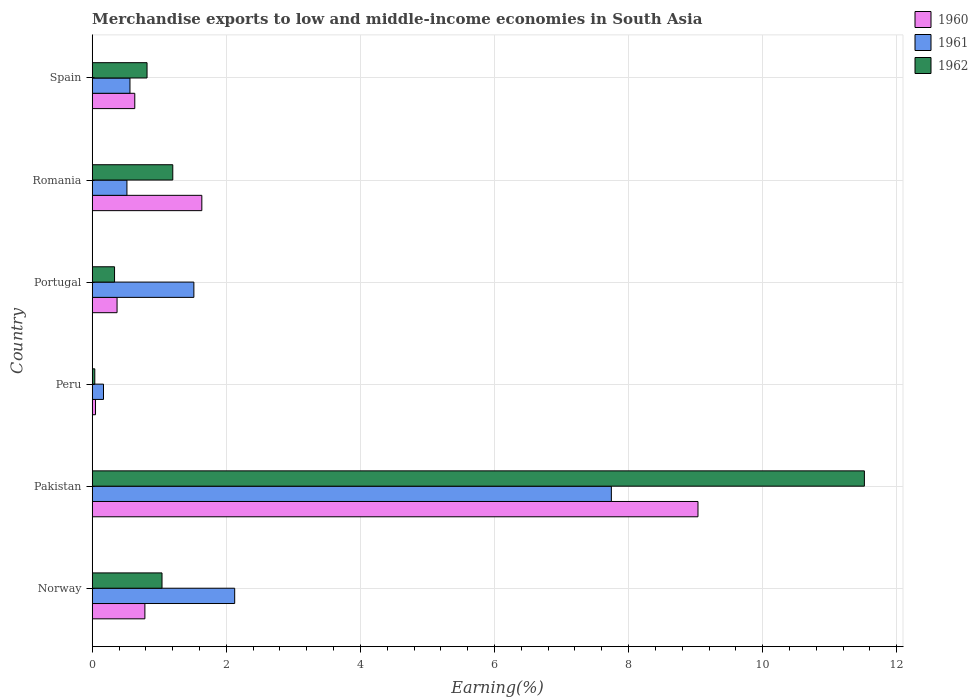How many different coloured bars are there?
Ensure brevity in your answer.  3. How many groups of bars are there?
Provide a short and direct response. 6. Are the number of bars per tick equal to the number of legend labels?
Your response must be concise. Yes. Are the number of bars on each tick of the Y-axis equal?
Keep it short and to the point. Yes. How many bars are there on the 3rd tick from the top?
Make the answer very short. 3. What is the label of the 2nd group of bars from the top?
Keep it short and to the point. Romania. In how many cases, is the number of bars for a given country not equal to the number of legend labels?
Offer a very short reply. 0. What is the percentage of amount earned from merchandise exports in 1960 in Portugal?
Your response must be concise. 0.37. Across all countries, what is the maximum percentage of amount earned from merchandise exports in 1962?
Provide a short and direct response. 11.52. Across all countries, what is the minimum percentage of amount earned from merchandise exports in 1961?
Provide a succinct answer. 0.17. In which country was the percentage of amount earned from merchandise exports in 1962 maximum?
Ensure brevity in your answer.  Pakistan. What is the total percentage of amount earned from merchandise exports in 1961 in the graph?
Your answer should be very brief. 12.63. What is the difference between the percentage of amount earned from merchandise exports in 1960 in Pakistan and that in Spain?
Make the answer very short. 8.4. What is the difference between the percentage of amount earned from merchandise exports in 1961 in Peru and the percentage of amount earned from merchandise exports in 1962 in Norway?
Make the answer very short. -0.87. What is the average percentage of amount earned from merchandise exports in 1960 per country?
Give a very brief answer. 2.08. What is the difference between the percentage of amount earned from merchandise exports in 1960 and percentage of amount earned from merchandise exports in 1961 in Portugal?
Provide a short and direct response. -1.15. What is the ratio of the percentage of amount earned from merchandise exports in 1962 in Romania to that in Spain?
Your response must be concise. 1.47. Is the percentage of amount earned from merchandise exports in 1961 in Norway less than that in Pakistan?
Keep it short and to the point. Yes. Is the difference between the percentage of amount earned from merchandise exports in 1960 in Portugal and Spain greater than the difference between the percentage of amount earned from merchandise exports in 1961 in Portugal and Spain?
Keep it short and to the point. No. What is the difference between the highest and the second highest percentage of amount earned from merchandise exports in 1961?
Your response must be concise. 5.62. What is the difference between the highest and the lowest percentage of amount earned from merchandise exports in 1962?
Your answer should be very brief. 11.48. Is the sum of the percentage of amount earned from merchandise exports in 1962 in Pakistan and Peru greater than the maximum percentage of amount earned from merchandise exports in 1961 across all countries?
Make the answer very short. Yes. What does the 2nd bar from the bottom in Peru represents?
Make the answer very short. 1961. What is the difference between two consecutive major ticks on the X-axis?
Your answer should be very brief. 2. Does the graph contain grids?
Your answer should be very brief. Yes. Where does the legend appear in the graph?
Provide a short and direct response. Top right. How many legend labels are there?
Give a very brief answer. 3. What is the title of the graph?
Make the answer very short. Merchandise exports to low and middle-income economies in South Asia. What is the label or title of the X-axis?
Provide a short and direct response. Earning(%). What is the label or title of the Y-axis?
Your answer should be compact. Country. What is the Earning(%) in 1960 in Norway?
Make the answer very short. 0.79. What is the Earning(%) of 1961 in Norway?
Your answer should be very brief. 2.12. What is the Earning(%) in 1962 in Norway?
Your response must be concise. 1.04. What is the Earning(%) of 1960 in Pakistan?
Your response must be concise. 9.04. What is the Earning(%) in 1961 in Pakistan?
Your response must be concise. 7.74. What is the Earning(%) of 1962 in Pakistan?
Your response must be concise. 11.52. What is the Earning(%) in 1960 in Peru?
Make the answer very short. 0.05. What is the Earning(%) in 1961 in Peru?
Your response must be concise. 0.17. What is the Earning(%) in 1962 in Peru?
Keep it short and to the point. 0.04. What is the Earning(%) in 1960 in Portugal?
Make the answer very short. 0.37. What is the Earning(%) in 1961 in Portugal?
Offer a terse response. 1.52. What is the Earning(%) of 1962 in Portugal?
Ensure brevity in your answer.  0.33. What is the Earning(%) of 1960 in Romania?
Make the answer very short. 1.63. What is the Earning(%) in 1961 in Romania?
Make the answer very short. 0.52. What is the Earning(%) in 1962 in Romania?
Give a very brief answer. 1.2. What is the Earning(%) in 1960 in Spain?
Make the answer very short. 0.63. What is the Earning(%) of 1961 in Spain?
Your response must be concise. 0.56. What is the Earning(%) of 1962 in Spain?
Your response must be concise. 0.82. Across all countries, what is the maximum Earning(%) in 1960?
Provide a succinct answer. 9.04. Across all countries, what is the maximum Earning(%) in 1961?
Offer a very short reply. 7.74. Across all countries, what is the maximum Earning(%) in 1962?
Make the answer very short. 11.52. Across all countries, what is the minimum Earning(%) of 1960?
Provide a short and direct response. 0.05. Across all countries, what is the minimum Earning(%) of 1961?
Offer a very short reply. 0.17. Across all countries, what is the minimum Earning(%) in 1962?
Provide a succinct answer. 0.04. What is the total Earning(%) of 1960 in the graph?
Your answer should be compact. 12.51. What is the total Earning(%) in 1961 in the graph?
Offer a terse response. 12.63. What is the total Earning(%) of 1962 in the graph?
Provide a short and direct response. 14.95. What is the difference between the Earning(%) of 1960 in Norway and that in Pakistan?
Make the answer very short. -8.25. What is the difference between the Earning(%) of 1961 in Norway and that in Pakistan?
Offer a very short reply. -5.62. What is the difference between the Earning(%) in 1962 in Norway and that in Pakistan?
Keep it short and to the point. -10.48. What is the difference between the Earning(%) of 1960 in Norway and that in Peru?
Offer a very short reply. 0.74. What is the difference between the Earning(%) in 1961 in Norway and that in Peru?
Provide a short and direct response. 1.96. What is the difference between the Earning(%) in 1962 in Norway and that in Peru?
Provide a succinct answer. 1. What is the difference between the Earning(%) of 1960 in Norway and that in Portugal?
Offer a terse response. 0.42. What is the difference between the Earning(%) in 1961 in Norway and that in Portugal?
Provide a short and direct response. 0.61. What is the difference between the Earning(%) in 1962 in Norway and that in Portugal?
Your answer should be compact. 0.71. What is the difference between the Earning(%) of 1960 in Norway and that in Romania?
Make the answer very short. -0.85. What is the difference between the Earning(%) of 1961 in Norway and that in Romania?
Offer a terse response. 1.61. What is the difference between the Earning(%) in 1962 in Norway and that in Romania?
Ensure brevity in your answer.  -0.16. What is the difference between the Earning(%) of 1960 in Norway and that in Spain?
Ensure brevity in your answer.  0.15. What is the difference between the Earning(%) of 1961 in Norway and that in Spain?
Provide a succinct answer. 1.56. What is the difference between the Earning(%) of 1962 in Norway and that in Spain?
Make the answer very short. 0.22. What is the difference between the Earning(%) of 1960 in Pakistan and that in Peru?
Your response must be concise. 8.99. What is the difference between the Earning(%) in 1961 in Pakistan and that in Peru?
Offer a terse response. 7.58. What is the difference between the Earning(%) of 1962 in Pakistan and that in Peru?
Ensure brevity in your answer.  11.48. What is the difference between the Earning(%) in 1960 in Pakistan and that in Portugal?
Offer a terse response. 8.67. What is the difference between the Earning(%) in 1961 in Pakistan and that in Portugal?
Provide a succinct answer. 6.23. What is the difference between the Earning(%) in 1962 in Pakistan and that in Portugal?
Make the answer very short. 11.18. What is the difference between the Earning(%) in 1960 in Pakistan and that in Romania?
Give a very brief answer. 7.4. What is the difference between the Earning(%) of 1961 in Pakistan and that in Romania?
Your answer should be very brief. 7.23. What is the difference between the Earning(%) of 1962 in Pakistan and that in Romania?
Provide a short and direct response. 10.32. What is the difference between the Earning(%) in 1960 in Pakistan and that in Spain?
Provide a succinct answer. 8.4. What is the difference between the Earning(%) of 1961 in Pakistan and that in Spain?
Your response must be concise. 7.18. What is the difference between the Earning(%) of 1962 in Pakistan and that in Spain?
Make the answer very short. 10.7. What is the difference between the Earning(%) of 1960 in Peru and that in Portugal?
Your answer should be compact. -0.32. What is the difference between the Earning(%) in 1961 in Peru and that in Portugal?
Keep it short and to the point. -1.35. What is the difference between the Earning(%) of 1962 in Peru and that in Portugal?
Your response must be concise. -0.29. What is the difference between the Earning(%) in 1960 in Peru and that in Romania?
Your answer should be compact. -1.59. What is the difference between the Earning(%) of 1961 in Peru and that in Romania?
Make the answer very short. -0.35. What is the difference between the Earning(%) of 1962 in Peru and that in Romania?
Offer a very short reply. -1.16. What is the difference between the Earning(%) in 1960 in Peru and that in Spain?
Provide a short and direct response. -0.59. What is the difference between the Earning(%) in 1961 in Peru and that in Spain?
Your answer should be compact. -0.39. What is the difference between the Earning(%) of 1962 in Peru and that in Spain?
Make the answer very short. -0.78. What is the difference between the Earning(%) of 1960 in Portugal and that in Romania?
Ensure brevity in your answer.  -1.26. What is the difference between the Earning(%) in 1961 in Portugal and that in Romania?
Make the answer very short. 1. What is the difference between the Earning(%) in 1962 in Portugal and that in Romania?
Keep it short and to the point. -0.87. What is the difference between the Earning(%) in 1960 in Portugal and that in Spain?
Provide a short and direct response. -0.26. What is the difference between the Earning(%) of 1961 in Portugal and that in Spain?
Give a very brief answer. 0.95. What is the difference between the Earning(%) in 1962 in Portugal and that in Spain?
Provide a short and direct response. -0.48. What is the difference between the Earning(%) in 1960 in Romania and that in Spain?
Your answer should be very brief. 1. What is the difference between the Earning(%) in 1961 in Romania and that in Spain?
Offer a terse response. -0.05. What is the difference between the Earning(%) of 1962 in Romania and that in Spain?
Your answer should be very brief. 0.38. What is the difference between the Earning(%) in 1960 in Norway and the Earning(%) in 1961 in Pakistan?
Keep it short and to the point. -6.96. What is the difference between the Earning(%) of 1960 in Norway and the Earning(%) of 1962 in Pakistan?
Provide a short and direct response. -10.73. What is the difference between the Earning(%) in 1961 in Norway and the Earning(%) in 1962 in Pakistan?
Keep it short and to the point. -9.39. What is the difference between the Earning(%) of 1960 in Norway and the Earning(%) of 1961 in Peru?
Make the answer very short. 0.62. What is the difference between the Earning(%) of 1960 in Norway and the Earning(%) of 1962 in Peru?
Offer a very short reply. 0.75. What is the difference between the Earning(%) of 1961 in Norway and the Earning(%) of 1962 in Peru?
Provide a succinct answer. 2.09. What is the difference between the Earning(%) of 1960 in Norway and the Earning(%) of 1961 in Portugal?
Give a very brief answer. -0.73. What is the difference between the Earning(%) in 1960 in Norway and the Earning(%) in 1962 in Portugal?
Offer a very short reply. 0.45. What is the difference between the Earning(%) in 1961 in Norway and the Earning(%) in 1962 in Portugal?
Your response must be concise. 1.79. What is the difference between the Earning(%) in 1960 in Norway and the Earning(%) in 1961 in Romania?
Your answer should be compact. 0.27. What is the difference between the Earning(%) in 1960 in Norway and the Earning(%) in 1962 in Romania?
Ensure brevity in your answer.  -0.42. What is the difference between the Earning(%) in 1961 in Norway and the Earning(%) in 1962 in Romania?
Your response must be concise. 0.92. What is the difference between the Earning(%) of 1960 in Norway and the Earning(%) of 1961 in Spain?
Make the answer very short. 0.22. What is the difference between the Earning(%) in 1960 in Norway and the Earning(%) in 1962 in Spain?
Keep it short and to the point. -0.03. What is the difference between the Earning(%) of 1961 in Norway and the Earning(%) of 1962 in Spain?
Offer a terse response. 1.31. What is the difference between the Earning(%) in 1960 in Pakistan and the Earning(%) in 1961 in Peru?
Make the answer very short. 8.87. What is the difference between the Earning(%) in 1960 in Pakistan and the Earning(%) in 1962 in Peru?
Make the answer very short. 9. What is the difference between the Earning(%) of 1961 in Pakistan and the Earning(%) of 1962 in Peru?
Give a very brief answer. 7.71. What is the difference between the Earning(%) of 1960 in Pakistan and the Earning(%) of 1961 in Portugal?
Offer a very short reply. 7.52. What is the difference between the Earning(%) in 1960 in Pakistan and the Earning(%) in 1962 in Portugal?
Your answer should be very brief. 8.7. What is the difference between the Earning(%) in 1961 in Pakistan and the Earning(%) in 1962 in Portugal?
Give a very brief answer. 7.41. What is the difference between the Earning(%) in 1960 in Pakistan and the Earning(%) in 1961 in Romania?
Provide a succinct answer. 8.52. What is the difference between the Earning(%) in 1960 in Pakistan and the Earning(%) in 1962 in Romania?
Make the answer very short. 7.83. What is the difference between the Earning(%) in 1961 in Pakistan and the Earning(%) in 1962 in Romania?
Offer a terse response. 6.54. What is the difference between the Earning(%) in 1960 in Pakistan and the Earning(%) in 1961 in Spain?
Ensure brevity in your answer.  8.47. What is the difference between the Earning(%) in 1960 in Pakistan and the Earning(%) in 1962 in Spain?
Give a very brief answer. 8.22. What is the difference between the Earning(%) of 1961 in Pakistan and the Earning(%) of 1962 in Spain?
Your answer should be very brief. 6.93. What is the difference between the Earning(%) of 1960 in Peru and the Earning(%) of 1961 in Portugal?
Your response must be concise. -1.47. What is the difference between the Earning(%) in 1960 in Peru and the Earning(%) in 1962 in Portugal?
Your response must be concise. -0.28. What is the difference between the Earning(%) in 1961 in Peru and the Earning(%) in 1962 in Portugal?
Make the answer very short. -0.16. What is the difference between the Earning(%) in 1960 in Peru and the Earning(%) in 1961 in Romania?
Keep it short and to the point. -0.47. What is the difference between the Earning(%) in 1960 in Peru and the Earning(%) in 1962 in Romania?
Give a very brief answer. -1.15. What is the difference between the Earning(%) in 1961 in Peru and the Earning(%) in 1962 in Romania?
Give a very brief answer. -1.03. What is the difference between the Earning(%) in 1960 in Peru and the Earning(%) in 1961 in Spain?
Your answer should be very brief. -0.51. What is the difference between the Earning(%) of 1960 in Peru and the Earning(%) of 1962 in Spain?
Keep it short and to the point. -0.77. What is the difference between the Earning(%) of 1961 in Peru and the Earning(%) of 1962 in Spain?
Your answer should be compact. -0.65. What is the difference between the Earning(%) of 1960 in Portugal and the Earning(%) of 1961 in Romania?
Provide a short and direct response. -0.15. What is the difference between the Earning(%) in 1960 in Portugal and the Earning(%) in 1962 in Romania?
Provide a short and direct response. -0.83. What is the difference between the Earning(%) in 1961 in Portugal and the Earning(%) in 1962 in Romania?
Provide a short and direct response. 0.31. What is the difference between the Earning(%) in 1960 in Portugal and the Earning(%) in 1961 in Spain?
Your answer should be very brief. -0.19. What is the difference between the Earning(%) of 1960 in Portugal and the Earning(%) of 1962 in Spain?
Make the answer very short. -0.45. What is the difference between the Earning(%) of 1961 in Portugal and the Earning(%) of 1962 in Spain?
Offer a terse response. 0.7. What is the difference between the Earning(%) in 1960 in Romania and the Earning(%) in 1961 in Spain?
Make the answer very short. 1.07. What is the difference between the Earning(%) in 1960 in Romania and the Earning(%) in 1962 in Spain?
Ensure brevity in your answer.  0.82. What is the average Earning(%) in 1960 per country?
Provide a short and direct response. 2.08. What is the average Earning(%) in 1961 per country?
Provide a short and direct response. 2.11. What is the average Earning(%) in 1962 per country?
Your answer should be compact. 2.49. What is the difference between the Earning(%) of 1960 and Earning(%) of 1961 in Norway?
Keep it short and to the point. -1.34. What is the difference between the Earning(%) of 1960 and Earning(%) of 1962 in Norway?
Provide a short and direct response. -0.26. What is the difference between the Earning(%) of 1961 and Earning(%) of 1962 in Norway?
Keep it short and to the point. 1.08. What is the difference between the Earning(%) in 1960 and Earning(%) in 1961 in Pakistan?
Offer a terse response. 1.29. What is the difference between the Earning(%) in 1960 and Earning(%) in 1962 in Pakistan?
Your answer should be compact. -2.48. What is the difference between the Earning(%) in 1961 and Earning(%) in 1962 in Pakistan?
Offer a very short reply. -3.77. What is the difference between the Earning(%) of 1960 and Earning(%) of 1961 in Peru?
Offer a terse response. -0.12. What is the difference between the Earning(%) of 1960 and Earning(%) of 1962 in Peru?
Offer a very short reply. 0.01. What is the difference between the Earning(%) in 1961 and Earning(%) in 1962 in Peru?
Make the answer very short. 0.13. What is the difference between the Earning(%) in 1960 and Earning(%) in 1961 in Portugal?
Your answer should be very brief. -1.15. What is the difference between the Earning(%) in 1960 and Earning(%) in 1962 in Portugal?
Make the answer very short. 0.04. What is the difference between the Earning(%) of 1961 and Earning(%) of 1962 in Portugal?
Keep it short and to the point. 1.18. What is the difference between the Earning(%) in 1960 and Earning(%) in 1961 in Romania?
Your response must be concise. 1.12. What is the difference between the Earning(%) of 1960 and Earning(%) of 1962 in Romania?
Make the answer very short. 0.43. What is the difference between the Earning(%) of 1961 and Earning(%) of 1962 in Romania?
Your answer should be very brief. -0.68. What is the difference between the Earning(%) of 1960 and Earning(%) of 1961 in Spain?
Your response must be concise. 0.07. What is the difference between the Earning(%) in 1960 and Earning(%) in 1962 in Spain?
Your answer should be very brief. -0.18. What is the difference between the Earning(%) of 1961 and Earning(%) of 1962 in Spain?
Your answer should be very brief. -0.25. What is the ratio of the Earning(%) of 1960 in Norway to that in Pakistan?
Provide a short and direct response. 0.09. What is the ratio of the Earning(%) of 1961 in Norway to that in Pakistan?
Ensure brevity in your answer.  0.27. What is the ratio of the Earning(%) in 1962 in Norway to that in Pakistan?
Provide a succinct answer. 0.09. What is the ratio of the Earning(%) of 1960 in Norway to that in Peru?
Keep it short and to the point. 16.05. What is the ratio of the Earning(%) in 1961 in Norway to that in Peru?
Keep it short and to the point. 12.65. What is the ratio of the Earning(%) in 1962 in Norway to that in Peru?
Your answer should be compact. 27.36. What is the ratio of the Earning(%) of 1960 in Norway to that in Portugal?
Your answer should be very brief. 2.12. What is the ratio of the Earning(%) of 1961 in Norway to that in Portugal?
Offer a terse response. 1.4. What is the ratio of the Earning(%) in 1962 in Norway to that in Portugal?
Provide a short and direct response. 3.13. What is the ratio of the Earning(%) of 1960 in Norway to that in Romania?
Provide a short and direct response. 0.48. What is the ratio of the Earning(%) in 1961 in Norway to that in Romania?
Offer a very short reply. 4.11. What is the ratio of the Earning(%) of 1962 in Norway to that in Romania?
Give a very brief answer. 0.87. What is the ratio of the Earning(%) in 1960 in Norway to that in Spain?
Offer a terse response. 1.24. What is the ratio of the Earning(%) of 1961 in Norway to that in Spain?
Offer a very short reply. 3.78. What is the ratio of the Earning(%) of 1962 in Norway to that in Spain?
Your answer should be compact. 1.27. What is the ratio of the Earning(%) in 1960 in Pakistan to that in Peru?
Your answer should be very brief. 184.68. What is the ratio of the Earning(%) of 1961 in Pakistan to that in Peru?
Your response must be concise. 46.1. What is the ratio of the Earning(%) of 1962 in Pakistan to that in Peru?
Your answer should be very brief. 302.79. What is the ratio of the Earning(%) in 1960 in Pakistan to that in Portugal?
Offer a terse response. 24.41. What is the ratio of the Earning(%) of 1961 in Pakistan to that in Portugal?
Your response must be concise. 5.11. What is the ratio of the Earning(%) of 1962 in Pakistan to that in Portugal?
Ensure brevity in your answer.  34.62. What is the ratio of the Earning(%) in 1960 in Pakistan to that in Romania?
Your response must be concise. 5.53. What is the ratio of the Earning(%) of 1961 in Pakistan to that in Romania?
Your response must be concise. 14.96. What is the ratio of the Earning(%) of 1962 in Pakistan to that in Romania?
Provide a short and direct response. 9.59. What is the ratio of the Earning(%) of 1960 in Pakistan to that in Spain?
Keep it short and to the point. 14.24. What is the ratio of the Earning(%) of 1961 in Pakistan to that in Spain?
Offer a very short reply. 13.76. What is the ratio of the Earning(%) of 1962 in Pakistan to that in Spain?
Offer a terse response. 14.09. What is the ratio of the Earning(%) in 1960 in Peru to that in Portugal?
Offer a terse response. 0.13. What is the ratio of the Earning(%) in 1961 in Peru to that in Portugal?
Provide a short and direct response. 0.11. What is the ratio of the Earning(%) of 1962 in Peru to that in Portugal?
Provide a short and direct response. 0.11. What is the ratio of the Earning(%) of 1960 in Peru to that in Romania?
Your answer should be very brief. 0.03. What is the ratio of the Earning(%) in 1961 in Peru to that in Romania?
Ensure brevity in your answer.  0.32. What is the ratio of the Earning(%) of 1962 in Peru to that in Romania?
Make the answer very short. 0.03. What is the ratio of the Earning(%) in 1960 in Peru to that in Spain?
Give a very brief answer. 0.08. What is the ratio of the Earning(%) in 1961 in Peru to that in Spain?
Ensure brevity in your answer.  0.3. What is the ratio of the Earning(%) of 1962 in Peru to that in Spain?
Ensure brevity in your answer.  0.05. What is the ratio of the Earning(%) in 1960 in Portugal to that in Romania?
Ensure brevity in your answer.  0.23. What is the ratio of the Earning(%) in 1961 in Portugal to that in Romania?
Offer a terse response. 2.93. What is the ratio of the Earning(%) in 1962 in Portugal to that in Romania?
Make the answer very short. 0.28. What is the ratio of the Earning(%) in 1960 in Portugal to that in Spain?
Keep it short and to the point. 0.58. What is the ratio of the Earning(%) in 1961 in Portugal to that in Spain?
Keep it short and to the point. 2.69. What is the ratio of the Earning(%) in 1962 in Portugal to that in Spain?
Your answer should be compact. 0.41. What is the ratio of the Earning(%) of 1960 in Romania to that in Spain?
Offer a terse response. 2.58. What is the ratio of the Earning(%) of 1961 in Romania to that in Spain?
Ensure brevity in your answer.  0.92. What is the ratio of the Earning(%) in 1962 in Romania to that in Spain?
Keep it short and to the point. 1.47. What is the difference between the highest and the second highest Earning(%) in 1960?
Your answer should be compact. 7.4. What is the difference between the highest and the second highest Earning(%) in 1961?
Provide a succinct answer. 5.62. What is the difference between the highest and the second highest Earning(%) in 1962?
Provide a short and direct response. 10.32. What is the difference between the highest and the lowest Earning(%) of 1960?
Offer a terse response. 8.99. What is the difference between the highest and the lowest Earning(%) of 1961?
Keep it short and to the point. 7.58. What is the difference between the highest and the lowest Earning(%) of 1962?
Give a very brief answer. 11.48. 